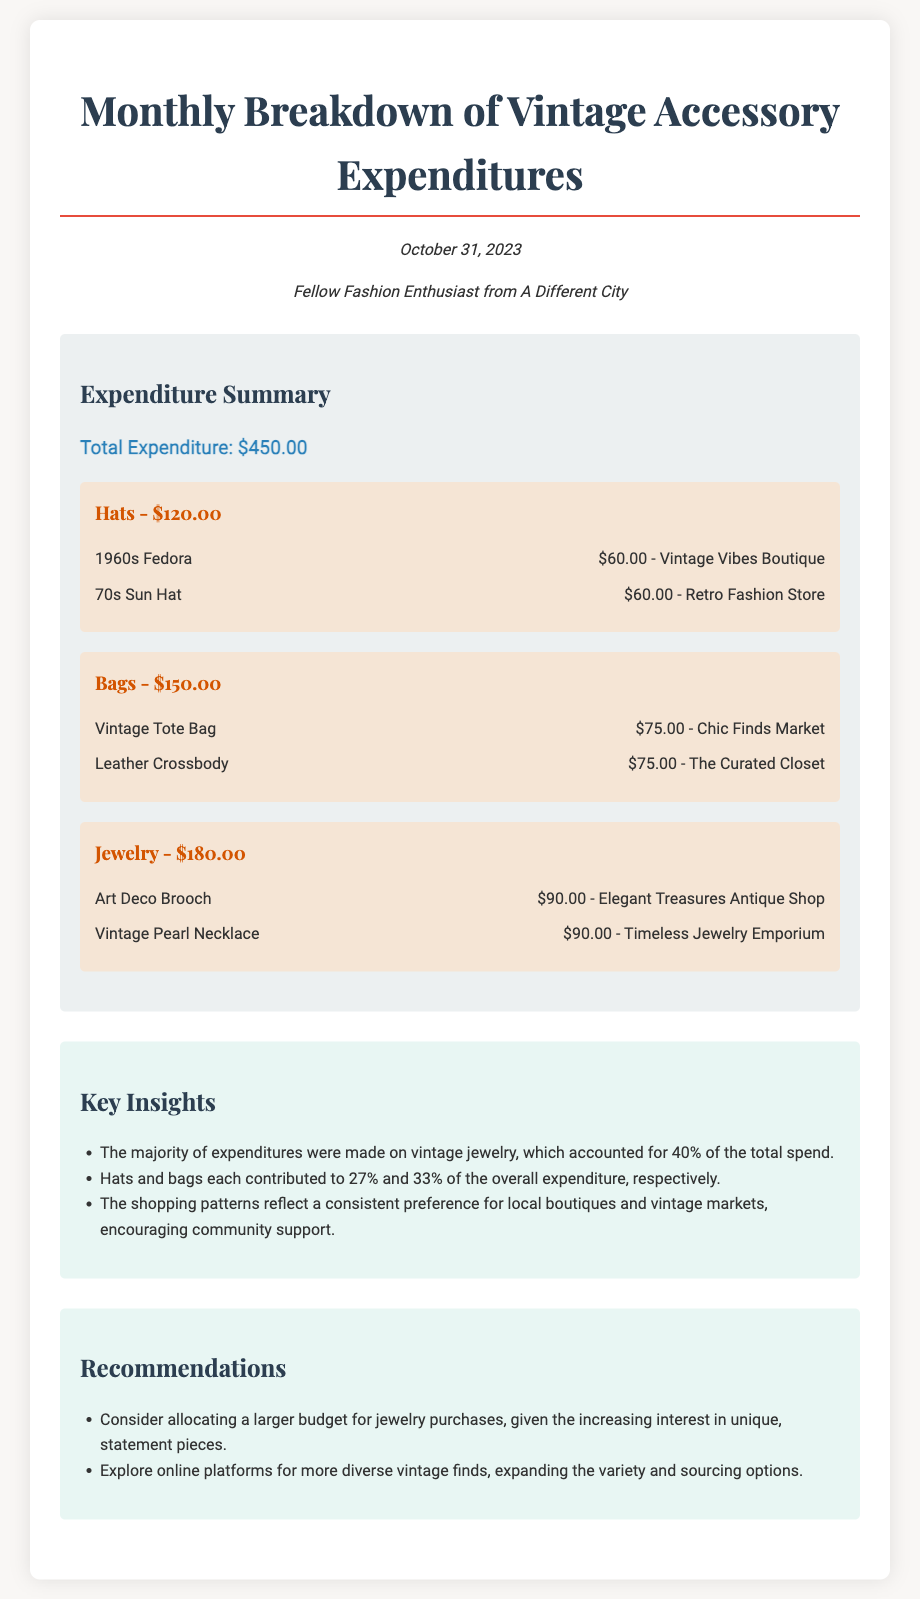What is the total expenditure for October 2023? The total expenditure is summarized at the top of the expenditures section of the document.
Answer: $450.00 Which category had the highest expenditure? By comparing the expenditure amounts for each category in the breakdown, the category with the highest amount can be identified.
Answer: Jewelry How much was spent on bags? The expenditure for the bags category is specifically stated in the document.
Answer: $150.00 What percentage of the total expenditure did jewelry account for? The document provides insights into the percentage contributions of each category to the total expenditure.
Answer: 40% What does the document recommend regarding jewelry purchases? The recommendations section outlines specific actions to enhance purchasing strategies based on insights.
Answer: Allocate a larger budget Which boutique sold the 1960s Fedora? The source for the purchase of the specific item is mentioned in the category breakdown.
Answer: Vintage Vibes Boutique What is the date of this financial report? The report's publication date is mentioned in the header information section.
Answer: October 31, 2023 How many items were listed under the bags category? The number of items under each expenditure category can be determined by counting the entries in that section.
Answer: 2 What is the color of the expenditure summary section? The background color of the expenditure summary is described in the document's styling and can be inferred from the visuals.
Answer: Light grey 